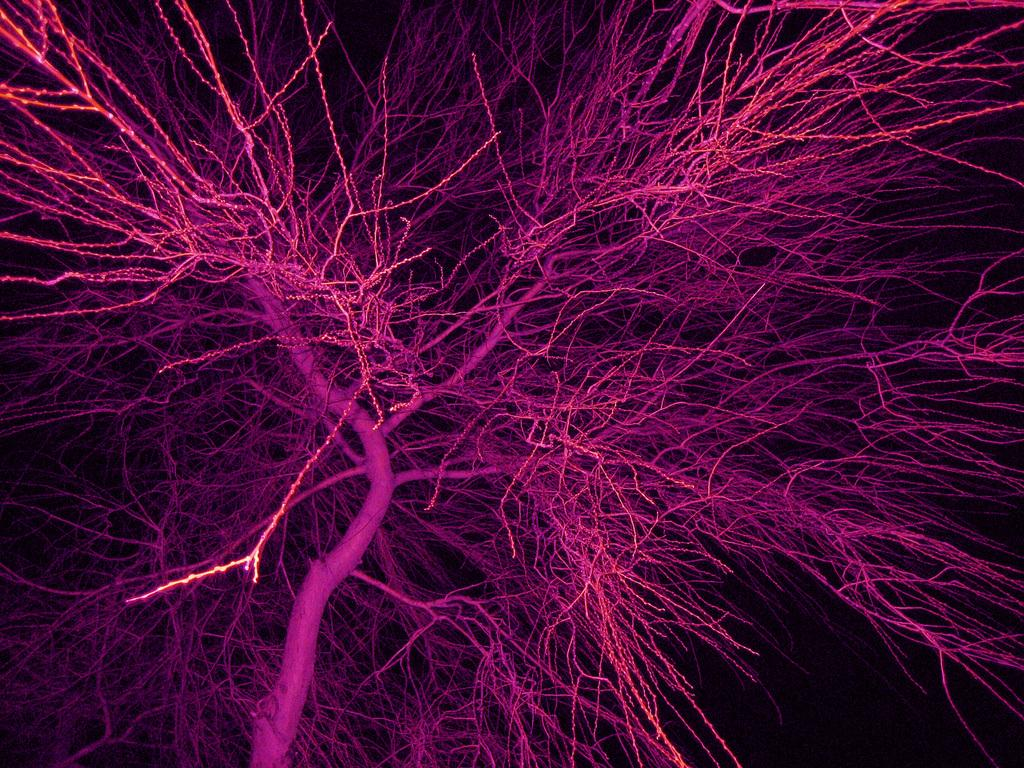What type of natural element can be seen in the image? There is a tree in the image. What is the source of illumination in the image? There is light in the image. How would you describe the overall brightness of the image? The background of the image is dark. How many pins can be seen attached to the tree in the image? There are no pins visible in the image; it only features a tree and light. What type of wealth is depicted in the image? There is no depiction of wealth in the image; it only features a tree and light. 